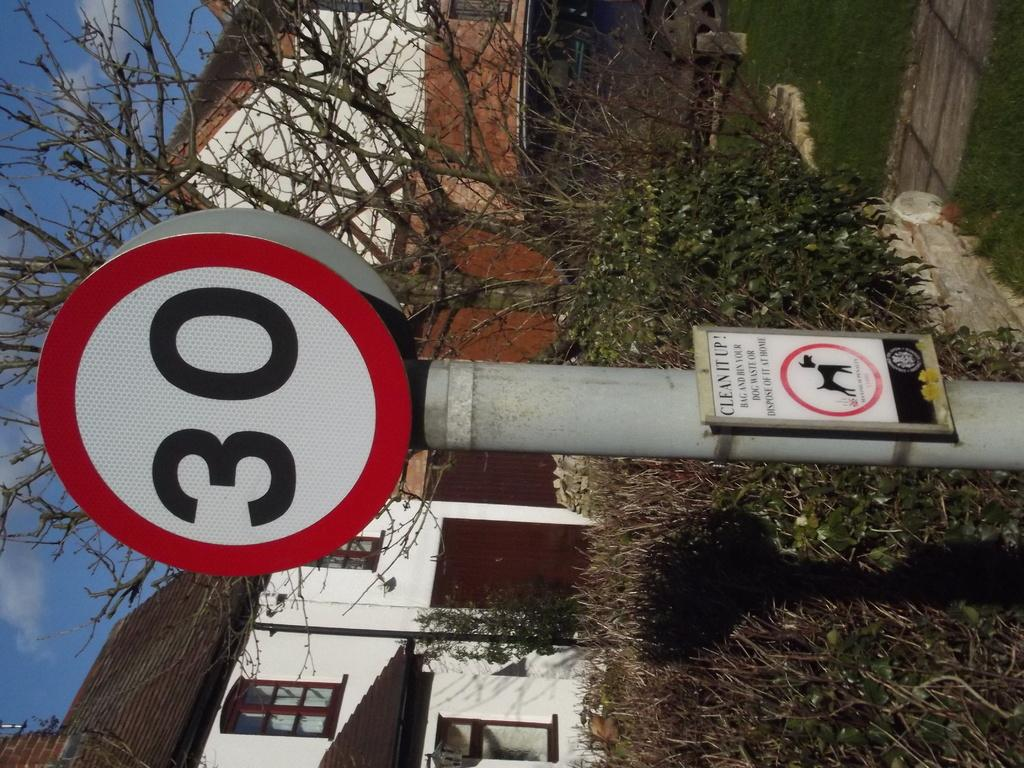What objects are in the foreground of the image? There is a pole and board in the image. What can be seen in the background of the image? There are plants, grass, and houses in the background of the image. What part of the sky is visible in the image? The sky is visible on the left side of the image. Can you describe the flock of birds flying over the houses in the image? There are no birds or flocks visible in the image; it only features a pole and board, plants, grass, houses, and the sky. 